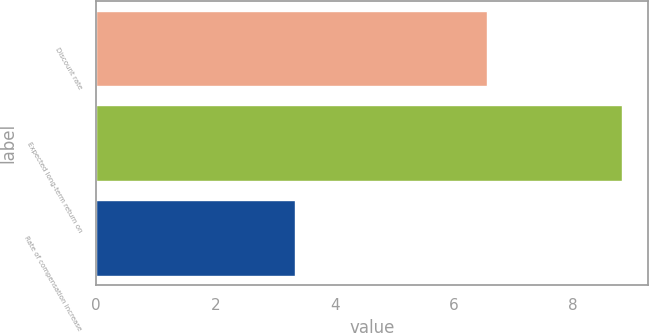<chart> <loc_0><loc_0><loc_500><loc_500><bar_chart><fcel>Discount rate<fcel>Expected long-term return on<fcel>Rate of compensation increase<nl><fcel>6.56<fcel>8.81<fcel>3.33<nl></chart> 